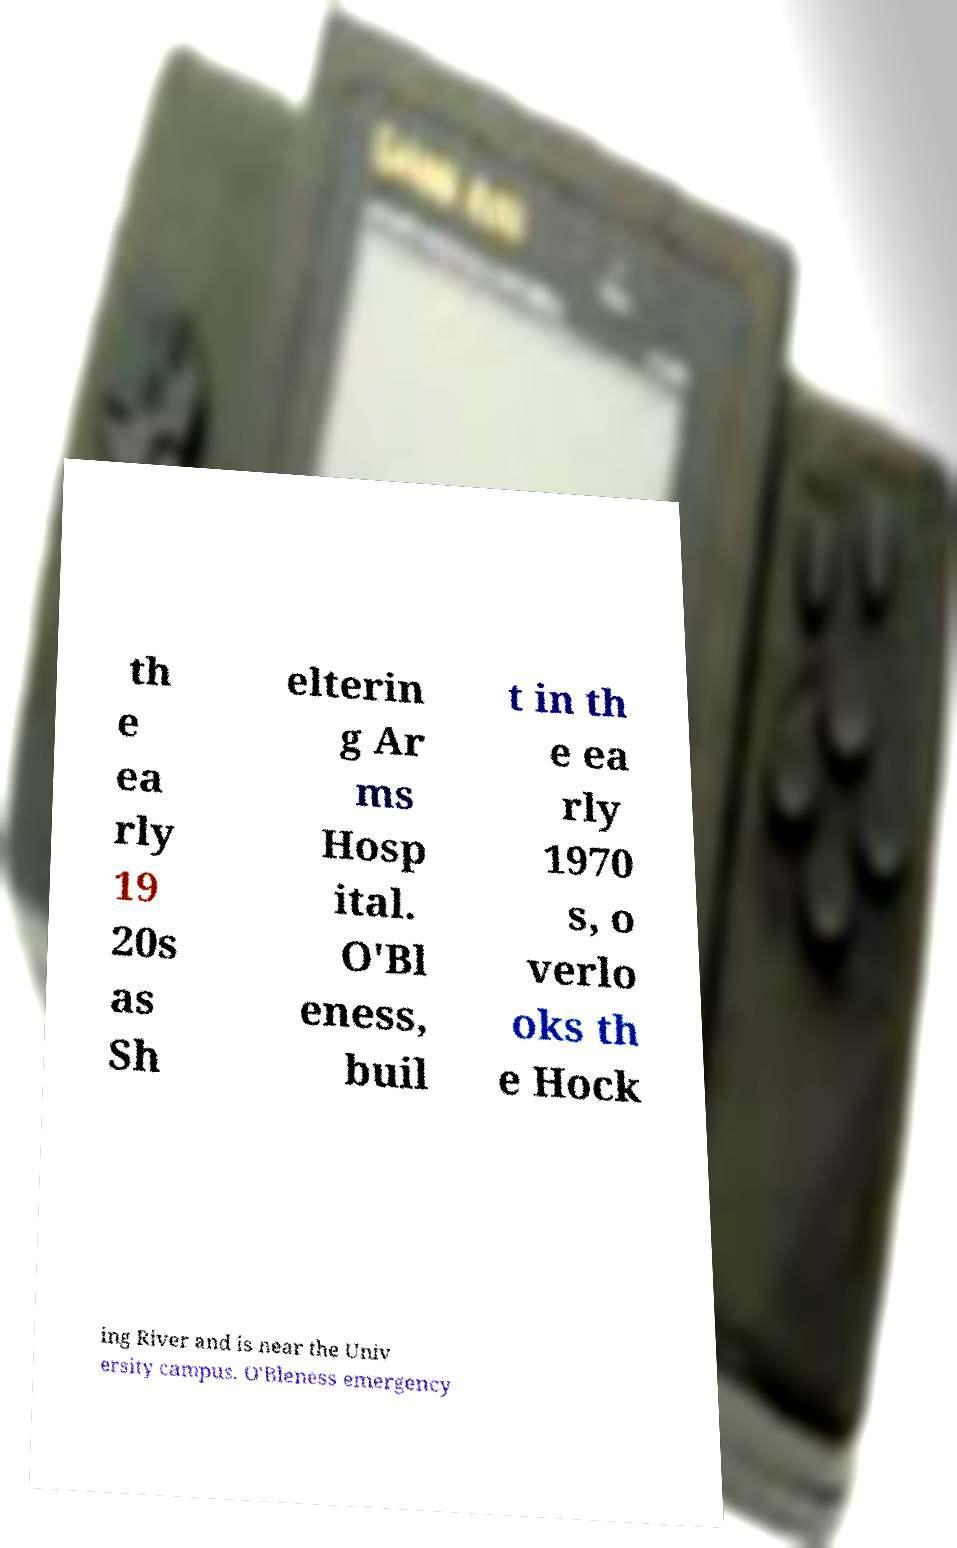Please read and relay the text visible in this image. What does it say? th e ea rly 19 20s as Sh elterin g Ar ms Hosp ital. O'Bl eness, buil t in th e ea rly 1970 s, o verlo oks th e Hock ing River and is near the Univ ersity campus. O'Bleness emergency 